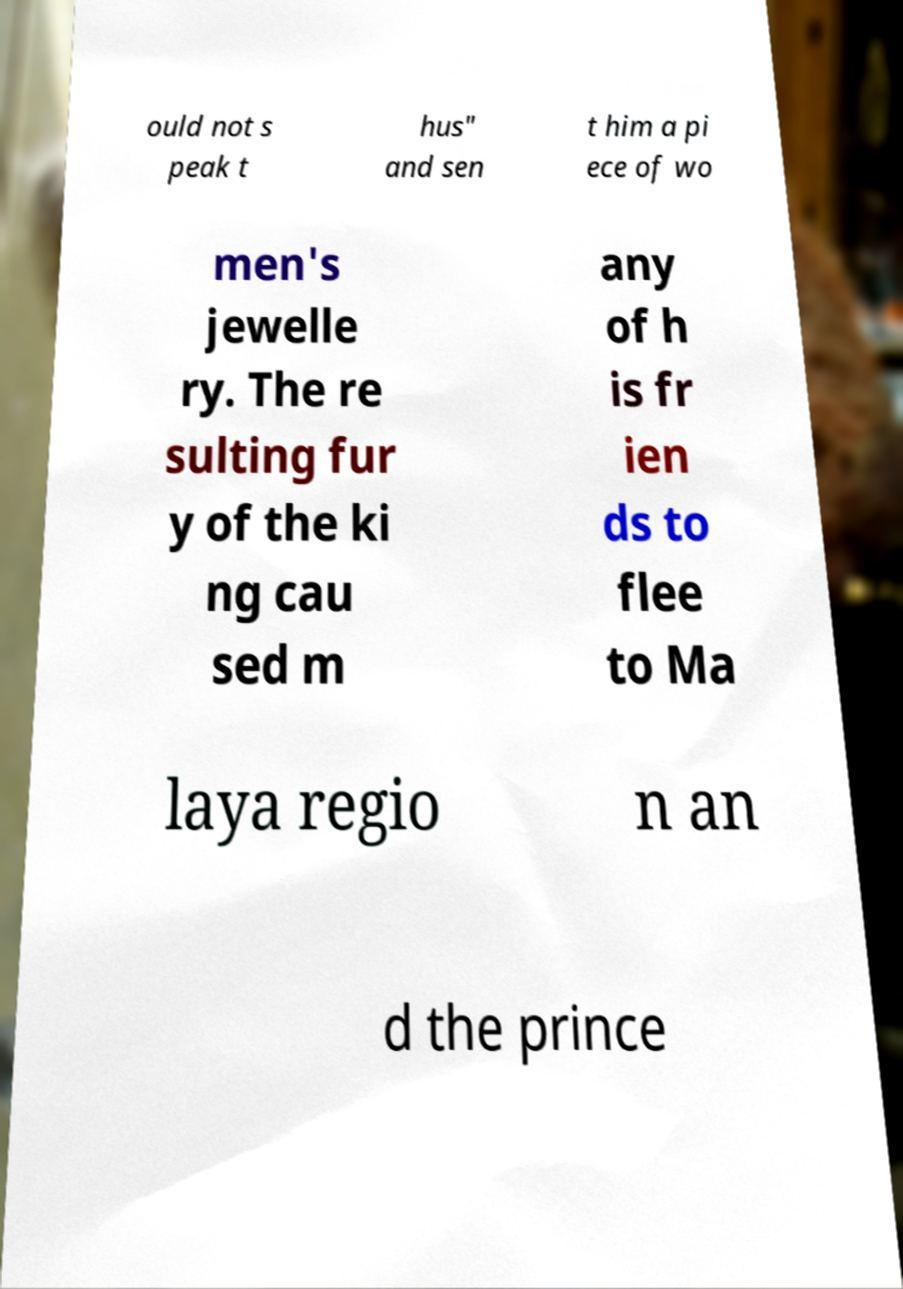Please identify and transcribe the text found in this image. ould not s peak t hus" and sen t him a pi ece of wo men's jewelle ry. The re sulting fur y of the ki ng cau sed m any of h is fr ien ds to flee to Ma laya regio n an d the prince 